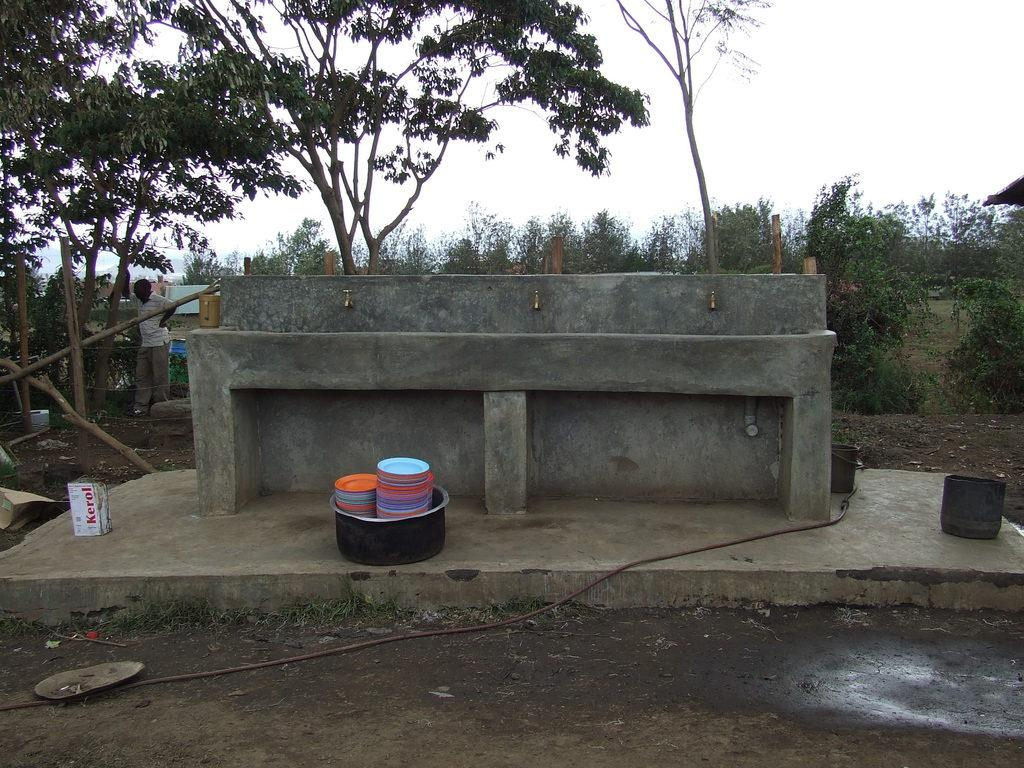What can be found in the image that is used for washing? There is a sink in the image that is used for washing. What is on the ground in the image? There are objects on the ground in the image. What type of natural vegetation is visible in the image? There are trees visible in the image. What structures can be seen in the image? There are poles in the image. Who or what is present in the image? There is a person in the image. What is visible in the background of the image? The sky is visible in the background of the image. Where is the sofa located in the image? There is no sofa present in the image. Can you see a door in the image? There is no door visible in the image. 